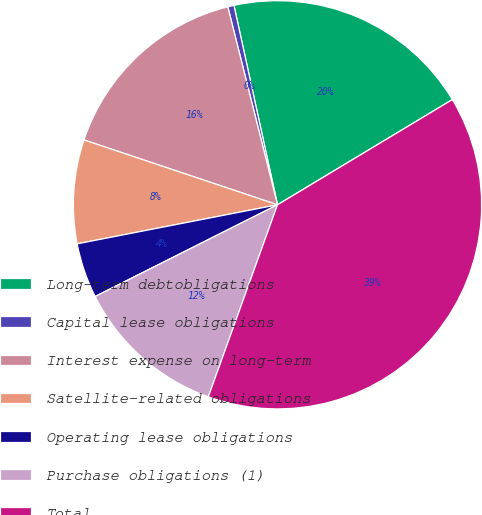Convert chart to OTSL. <chart><loc_0><loc_0><loc_500><loc_500><pie_chart><fcel>Long-term debtobligations<fcel>Capital lease obligations<fcel>Interest expense on long-term<fcel>Satellite-related obligations<fcel>Operating lease obligations<fcel>Purchase obligations (1)<fcel>Total<nl><fcel>19.8%<fcel>0.49%<fcel>15.94%<fcel>8.21%<fcel>4.35%<fcel>12.08%<fcel>39.12%<nl></chart> 